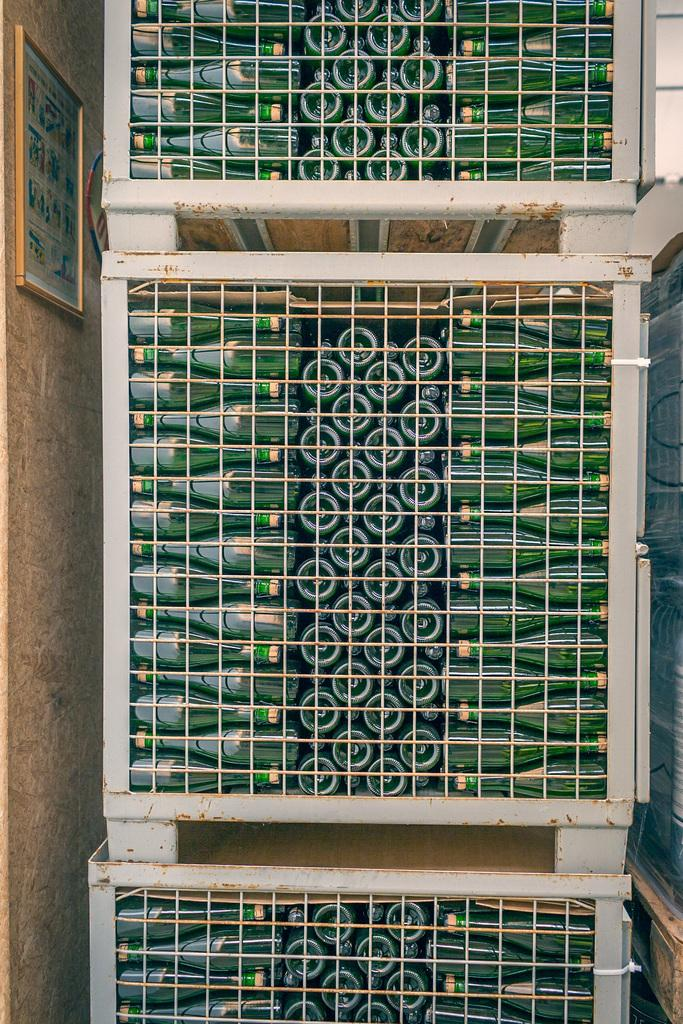What is located in the center of the image? There are three boxes in the center of the image. What is inside the boxes? The boxes contain green color bottles. What can be seen in the background of the image? There is a wall, a photo frame, and a glass object in the background of the image. Are there any other objects visible in the background? Yes, there are a few other objects in the background of the image. What is the creature's opinion about the green color bottles in the image? There is no creature present in the image, and therefore no opinion can be attributed to it. 